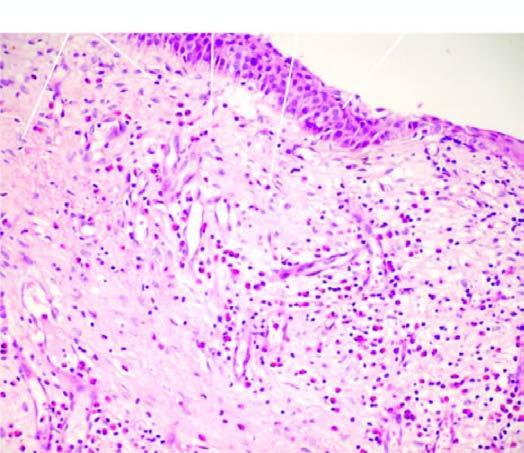s the overlying mucosa covered partly by respiratory and partly by squamous metaplastic epithelium?
Answer the question using a single word or phrase. Yes 